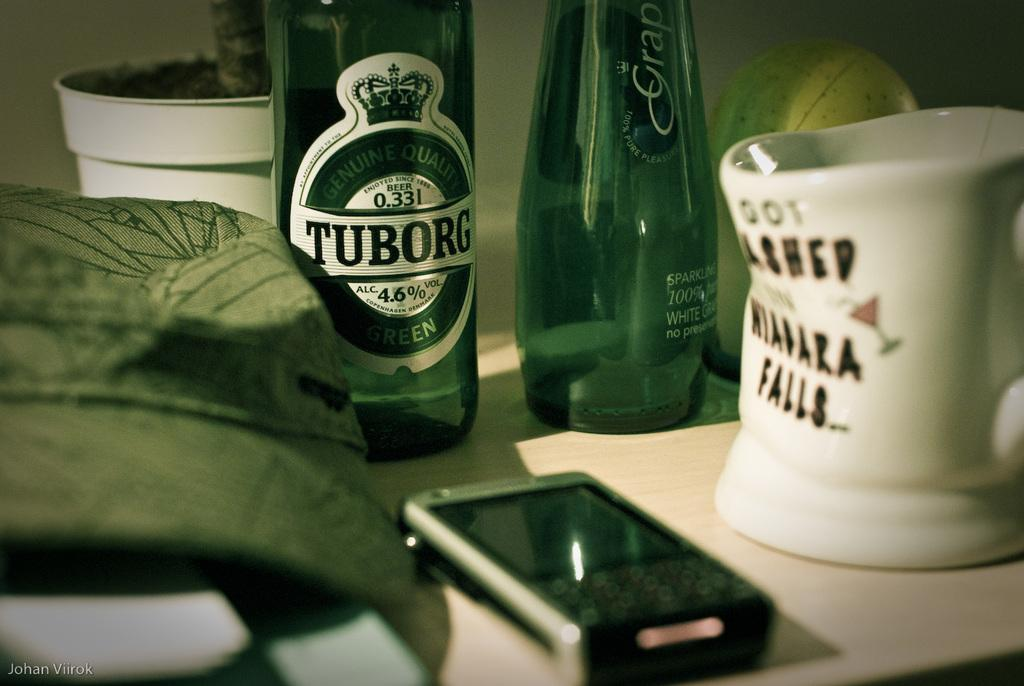What piece of furniture is present in the image? There is a table in the image. What electronic device can be seen on the table? There is a mobile phone on the table. What type of material is covering the table? There is cloth on the table. What type of container is on the table? There is a pot on the table. What type of beverage containers are on the table? There are bottles on the table. What type of drinking vessel is on the table? There is a cup on the table. What type of fiction is being read from the table in the image? There is no fiction present in the image; it only shows a table with various objects on it. How many snakes can be seen slithering on the table in the image? There are no snakes present in the image; it only shows a table with various objects on it. 